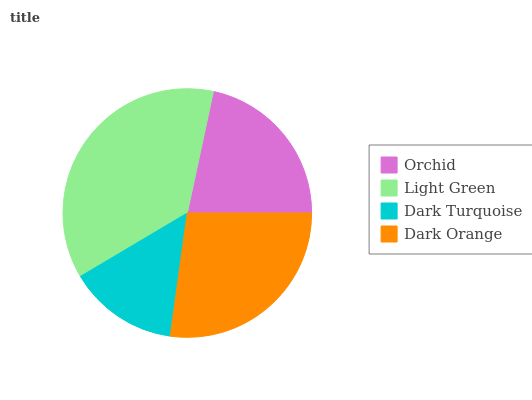Is Dark Turquoise the minimum?
Answer yes or no. Yes. Is Light Green the maximum?
Answer yes or no. Yes. Is Light Green the minimum?
Answer yes or no. No. Is Dark Turquoise the maximum?
Answer yes or no. No. Is Light Green greater than Dark Turquoise?
Answer yes or no. Yes. Is Dark Turquoise less than Light Green?
Answer yes or no. Yes. Is Dark Turquoise greater than Light Green?
Answer yes or no. No. Is Light Green less than Dark Turquoise?
Answer yes or no. No. Is Dark Orange the high median?
Answer yes or no. Yes. Is Orchid the low median?
Answer yes or no. Yes. Is Orchid the high median?
Answer yes or no. No. Is Dark Turquoise the low median?
Answer yes or no. No. 